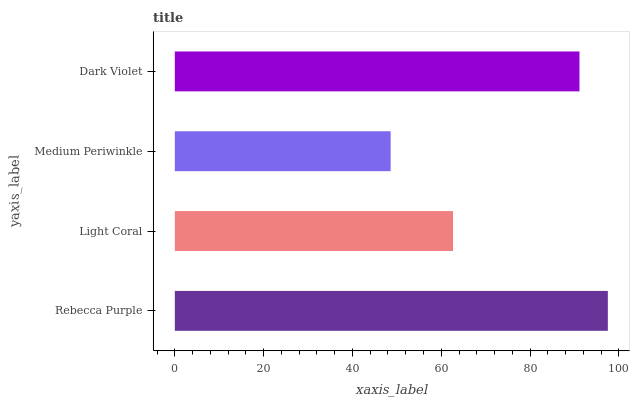Is Medium Periwinkle the minimum?
Answer yes or no. Yes. Is Rebecca Purple the maximum?
Answer yes or no. Yes. Is Light Coral the minimum?
Answer yes or no. No. Is Light Coral the maximum?
Answer yes or no. No. Is Rebecca Purple greater than Light Coral?
Answer yes or no. Yes. Is Light Coral less than Rebecca Purple?
Answer yes or no. Yes. Is Light Coral greater than Rebecca Purple?
Answer yes or no. No. Is Rebecca Purple less than Light Coral?
Answer yes or no. No. Is Dark Violet the high median?
Answer yes or no. Yes. Is Light Coral the low median?
Answer yes or no. Yes. Is Medium Periwinkle the high median?
Answer yes or no. No. Is Dark Violet the low median?
Answer yes or no. No. 